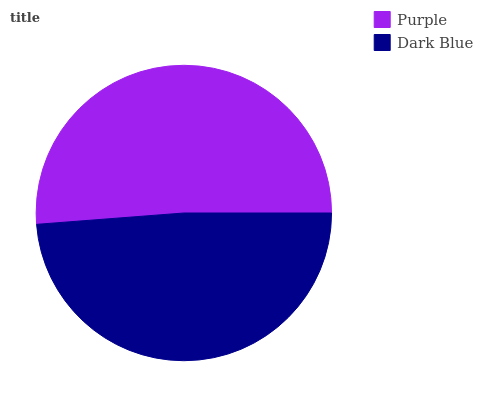Is Dark Blue the minimum?
Answer yes or no. Yes. Is Purple the maximum?
Answer yes or no. Yes. Is Dark Blue the maximum?
Answer yes or no. No. Is Purple greater than Dark Blue?
Answer yes or no. Yes. Is Dark Blue less than Purple?
Answer yes or no. Yes. Is Dark Blue greater than Purple?
Answer yes or no. No. Is Purple less than Dark Blue?
Answer yes or no. No. Is Purple the high median?
Answer yes or no. Yes. Is Dark Blue the low median?
Answer yes or no. Yes. Is Dark Blue the high median?
Answer yes or no. No. Is Purple the low median?
Answer yes or no. No. 